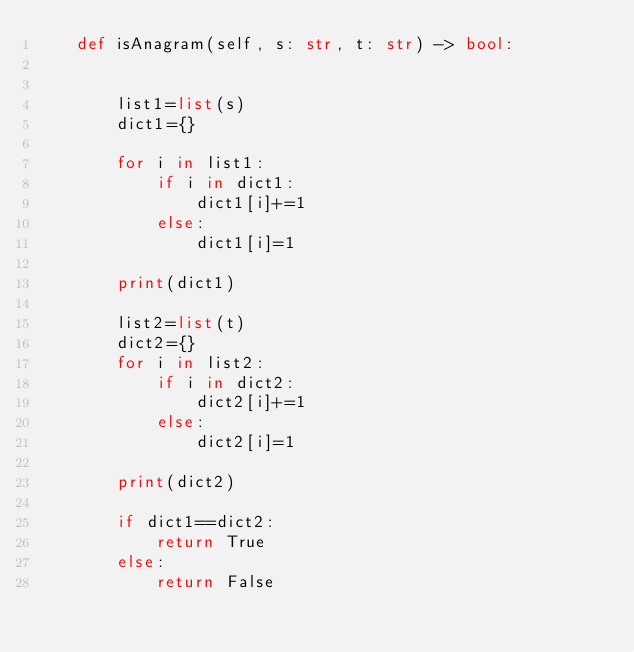Convert code to text. <code><loc_0><loc_0><loc_500><loc_500><_Python_>    def isAnagram(self, s: str, t: str) -> bool:
        
        
        list1=list(s)
        dict1={}
        
        for i in list1:
            if i in dict1:
                dict1[i]+=1
            else:
                dict1[i]=1
        
        print(dict1)
        
        list2=list(t)
        dict2={}
        for i in list2:
            if i in dict2:
                dict2[i]+=1
            else:
                dict2[i]=1
                
        print(dict2)
        
        if dict1==dict2:
            return True
        else:
            return False
</code> 